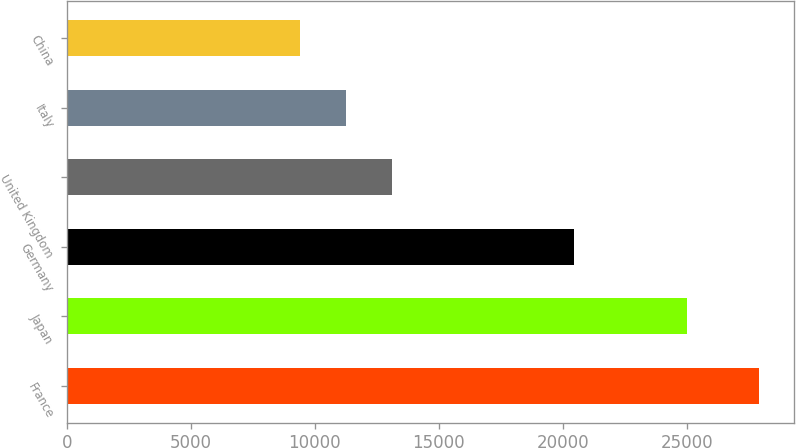Convert chart. <chart><loc_0><loc_0><loc_500><loc_500><bar_chart><fcel>France<fcel>Japan<fcel>Germany<fcel>United Kingdom<fcel>Italy<fcel>China<nl><fcel>27923<fcel>24998<fcel>20470<fcel>13112.6<fcel>11261.3<fcel>9410<nl></chart> 